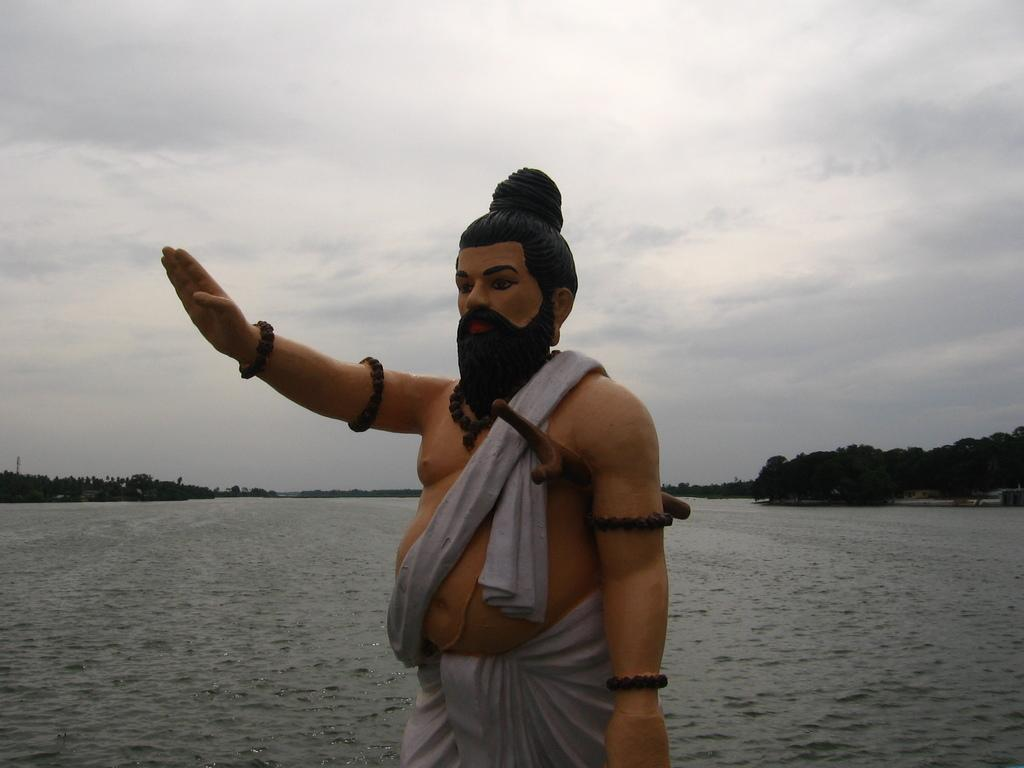What is the main subject in the image? There is a statue in the image. What can be seen in the background of the image? There is water and trees visible in the background of the image. What type of music is being played by the statue in the image? There is no music being played by the statue in the image, as it is a stationary object. 